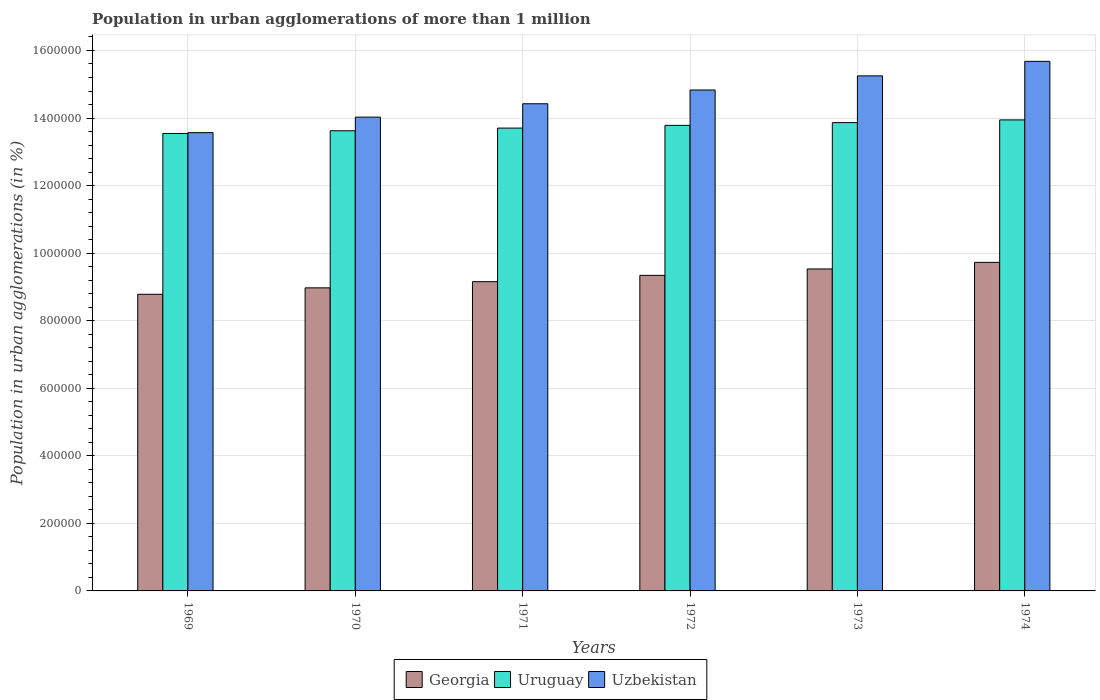How many groups of bars are there?
Your response must be concise. 6. Are the number of bars per tick equal to the number of legend labels?
Offer a very short reply. Yes. What is the label of the 2nd group of bars from the left?
Your answer should be compact. 1970. What is the population in urban agglomerations in Uzbekistan in 1973?
Provide a succinct answer. 1.52e+06. Across all years, what is the maximum population in urban agglomerations in Georgia?
Provide a succinct answer. 9.73e+05. Across all years, what is the minimum population in urban agglomerations in Uruguay?
Provide a short and direct response. 1.35e+06. In which year was the population in urban agglomerations in Uzbekistan maximum?
Provide a succinct answer. 1974. In which year was the population in urban agglomerations in Uzbekistan minimum?
Make the answer very short. 1969. What is the total population in urban agglomerations in Georgia in the graph?
Give a very brief answer. 5.55e+06. What is the difference between the population in urban agglomerations in Uzbekistan in 1969 and that in 1974?
Give a very brief answer. -2.11e+05. What is the difference between the population in urban agglomerations in Uzbekistan in 1974 and the population in urban agglomerations in Uruguay in 1972?
Offer a very short reply. 1.90e+05. What is the average population in urban agglomerations in Uzbekistan per year?
Offer a very short reply. 1.46e+06. In the year 1970, what is the difference between the population in urban agglomerations in Uzbekistan and population in urban agglomerations in Georgia?
Your answer should be compact. 5.05e+05. What is the ratio of the population in urban agglomerations in Georgia in 1970 to that in 1972?
Provide a succinct answer. 0.96. Is the population in urban agglomerations in Uzbekistan in 1969 less than that in 1973?
Provide a succinct answer. Yes. Is the difference between the population in urban agglomerations in Uzbekistan in 1973 and 1974 greater than the difference between the population in urban agglomerations in Georgia in 1973 and 1974?
Offer a very short reply. No. What is the difference between the highest and the second highest population in urban agglomerations in Uzbekistan?
Your answer should be compact. 4.30e+04. What is the difference between the highest and the lowest population in urban agglomerations in Georgia?
Make the answer very short. 9.44e+04. Is the sum of the population in urban agglomerations in Georgia in 1969 and 1974 greater than the maximum population in urban agglomerations in Uzbekistan across all years?
Your response must be concise. Yes. What does the 2nd bar from the left in 1974 represents?
Offer a terse response. Uruguay. What does the 2nd bar from the right in 1973 represents?
Offer a very short reply. Uruguay. Is it the case that in every year, the sum of the population in urban agglomerations in Georgia and population in urban agglomerations in Uzbekistan is greater than the population in urban agglomerations in Uruguay?
Ensure brevity in your answer.  Yes. How many bars are there?
Provide a short and direct response. 18. How many years are there in the graph?
Your answer should be compact. 6. Where does the legend appear in the graph?
Your answer should be compact. Bottom center. What is the title of the graph?
Provide a short and direct response. Population in urban agglomerations of more than 1 million. Does "Equatorial Guinea" appear as one of the legend labels in the graph?
Give a very brief answer. No. What is the label or title of the X-axis?
Keep it short and to the point. Years. What is the label or title of the Y-axis?
Offer a terse response. Population in urban agglomerations (in %). What is the Population in urban agglomerations (in %) of Georgia in 1969?
Offer a terse response. 8.78e+05. What is the Population in urban agglomerations (in %) in Uruguay in 1969?
Keep it short and to the point. 1.35e+06. What is the Population in urban agglomerations (in %) in Uzbekistan in 1969?
Make the answer very short. 1.36e+06. What is the Population in urban agglomerations (in %) in Georgia in 1970?
Your answer should be very brief. 8.97e+05. What is the Population in urban agglomerations (in %) in Uruguay in 1970?
Ensure brevity in your answer.  1.36e+06. What is the Population in urban agglomerations (in %) in Uzbekistan in 1970?
Offer a terse response. 1.40e+06. What is the Population in urban agglomerations (in %) in Georgia in 1971?
Your response must be concise. 9.16e+05. What is the Population in urban agglomerations (in %) of Uruguay in 1971?
Your answer should be compact. 1.37e+06. What is the Population in urban agglomerations (in %) in Uzbekistan in 1971?
Ensure brevity in your answer.  1.44e+06. What is the Population in urban agglomerations (in %) in Georgia in 1972?
Offer a very short reply. 9.34e+05. What is the Population in urban agglomerations (in %) of Uruguay in 1972?
Your answer should be very brief. 1.38e+06. What is the Population in urban agglomerations (in %) in Uzbekistan in 1972?
Your response must be concise. 1.48e+06. What is the Population in urban agglomerations (in %) in Georgia in 1973?
Your answer should be very brief. 9.53e+05. What is the Population in urban agglomerations (in %) in Uruguay in 1973?
Make the answer very short. 1.39e+06. What is the Population in urban agglomerations (in %) of Uzbekistan in 1973?
Provide a succinct answer. 1.52e+06. What is the Population in urban agglomerations (in %) in Georgia in 1974?
Provide a succinct answer. 9.73e+05. What is the Population in urban agglomerations (in %) in Uruguay in 1974?
Make the answer very short. 1.39e+06. What is the Population in urban agglomerations (in %) in Uzbekistan in 1974?
Offer a terse response. 1.57e+06. Across all years, what is the maximum Population in urban agglomerations (in %) of Georgia?
Offer a very short reply. 9.73e+05. Across all years, what is the maximum Population in urban agglomerations (in %) in Uruguay?
Make the answer very short. 1.39e+06. Across all years, what is the maximum Population in urban agglomerations (in %) in Uzbekistan?
Your answer should be very brief. 1.57e+06. Across all years, what is the minimum Population in urban agglomerations (in %) of Georgia?
Your response must be concise. 8.78e+05. Across all years, what is the minimum Population in urban agglomerations (in %) in Uruguay?
Your answer should be compact. 1.35e+06. Across all years, what is the minimum Population in urban agglomerations (in %) in Uzbekistan?
Provide a short and direct response. 1.36e+06. What is the total Population in urban agglomerations (in %) of Georgia in the graph?
Keep it short and to the point. 5.55e+06. What is the total Population in urban agglomerations (in %) in Uruguay in the graph?
Your answer should be very brief. 8.25e+06. What is the total Population in urban agglomerations (in %) of Uzbekistan in the graph?
Offer a very short reply. 8.78e+06. What is the difference between the Population in urban agglomerations (in %) in Georgia in 1969 and that in 1970?
Keep it short and to the point. -1.90e+04. What is the difference between the Population in urban agglomerations (in %) of Uruguay in 1969 and that in 1970?
Ensure brevity in your answer.  -7940. What is the difference between the Population in urban agglomerations (in %) in Uzbekistan in 1969 and that in 1970?
Give a very brief answer. -4.60e+04. What is the difference between the Population in urban agglomerations (in %) in Georgia in 1969 and that in 1971?
Offer a terse response. -3.73e+04. What is the difference between the Population in urban agglomerations (in %) in Uruguay in 1969 and that in 1971?
Make the answer very short. -1.59e+04. What is the difference between the Population in urban agglomerations (in %) of Uzbekistan in 1969 and that in 1971?
Give a very brief answer. -8.56e+04. What is the difference between the Population in urban agglomerations (in %) in Georgia in 1969 and that in 1972?
Keep it short and to the point. -5.60e+04. What is the difference between the Population in urban agglomerations (in %) of Uruguay in 1969 and that in 1972?
Your response must be concise. -2.40e+04. What is the difference between the Population in urban agglomerations (in %) in Uzbekistan in 1969 and that in 1972?
Provide a short and direct response. -1.26e+05. What is the difference between the Population in urban agglomerations (in %) of Georgia in 1969 and that in 1973?
Provide a succinct answer. -7.50e+04. What is the difference between the Population in urban agglomerations (in %) in Uruguay in 1969 and that in 1973?
Your answer should be very brief. -3.20e+04. What is the difference between the Population in urban agglomerations (in %) of Uzbekistan in 1969 and that in 1973?
Provide a succinct answer. -1.68e+05. What is the difference between the Population in urban agglomerations (in %) in Georgia in 1969 and that in 1974?
Ensure brevity in your answer.  -9.44e+04. What is the difference between the Population in urban agglomerations (in %) in Uruguay in 1969 and that in 1974?
Your answer should be compact. -4.02e+04. What is the difference between the Population in urban agglomerations (in %) of Uzbekistan in 1969 and that in 1974?
Provide a succinct answer. -2.11e+05. What is the difference between the Population in urban agglomerations (in %) in Georgia in 1970 and that in 1971?
Your answer should be very brief. -1.83e+04. What is the difference between the Population in urban agglomerations (in %) in Uruguay in 1970 and that in 1971?
Give a very brief answer. -7987. What is the difference between the Population in urban agglomerations (in %) of Uzbekistan in 1970 and that in 1971?
Ensure brevity in your answer.  -3.96e+04. What is the difference between the Population in urban agglomerations (in %) in Georgia in 1970 and that in 1972?
Your answer should be very brief. -3.70e+04. What is the difference between the Population in urban agglomerations (in %) of Uruguay in 1970 and that in 1972?
Give a very brief answer. -1.60e+04. What is the difference between the Population in urban agglomerations (in %) in Uzbekistan in 1970 and that in 1972?
Make the answer very short. -8.03e+04. What is the difference between the Population in urban agglomerations (in %) of Georgia in 1970 and that in 1973?
Ensure brevity in your answer.  -5.60e+04. What is the difference between the Population in urban agglomerations (in %) of Uruguay in 1970 and that in 1973?
Your answer should be very brief. -2.41e+04. What is the difference between the Population in urban agglomerations (in %) in Uzbekistan in 1970 and that in 1973?
Your response must be concise. -1.22e+05. What is the difference between the Population in urban agglomerations (in %) of Georgia in 1970 and that in 1974?
Offer a terse response. -7.54e+04. What is the difference between the Population in urban agglomerations (in %) of Uruguay in 1970 and that in 1974?
Provide a succinct answer. -3.22e+04. What is the difference between the Population in urban agglomerations (in %) in Uzbekistan in 1970 and that in 1974?
Offer a very short reply. -1.65e+05. What is the difference between the Population in urban agglomerations (in %) of Georgia in 1971 and that in 1972?
Keep it short and to the point. -1.87e+04. What is the difference between the Population in urban agglomerations (in %) in Uruguay in 1971 and that in 1972?
Offer a very short reply. -8044. What is the difference between the Population in urban agglomerations (in %) in Uzbekistan in 1971 and that in 1972?
Your answer should be compact. -4.07e+04. What is the difference between the Population in urban agglomerations (in %) in Georgia in 1971 and that in 1973?
Your answer should be very brief. -3.77e+04. What is the difference between the Population in urban agglomerations (in %) in Uruguay in 1971 and that in 1973?
Give a very brief answer. -1.61e+04. What is the difference between the Population in urban agglomerations (in %) of Uzbekistan in 1971 and that in 1973?
Your answer should be very brief. -8.25e+04. What is the difference between the Population in urban agglomerations (in %) in Georgia in 1971 and that in 1974?
Offer a terse response. -5.71e+04. What is the difference between the Population in urban agglomerations (in %) of Uruguay in 1971 and that in 1974?
Keep it short and to the point. -2.42e+04. What is the difference between the Population in urban agglomerations (in %) in Uzbekistan in 1971 and that in 1974?
Give a very brief answer. -1.26e+05. What is the difference between the Population in urban agglomerations (in %) in Georgia in 1972 and that in 1973?
Provide a succinct answer. -1.90e+04. What is the difference between the Population in urban agglomerations (in %) in Uruguay in 1972 and that in 1973?
Offer a terse response. -8070. What is the difference between the Population in urban agglomerations (in %) of Uzbekistan in 1972 and that in 1973?
Keep it short and to the point. -4.18e+04. What is the difference between the Population in urban agglomerations (in %) in Georgia in 1972 and that in 1974?
Give a very brief answer. -3.84e+04. What is the difference between the Population in urban agglomerations (in %) of Uruguay in 1972 and that in 1974?
Your answer should be compact. -1.62e+04. What is the difference between the Population in urban agglomerations (in %) in Uzbekistan in 1972 and that in 1974?
Make the answer very short. -8.48e+04. What is the difference between the Population in urban agglomerations (in %) of Georgia in 1973 and that in 1974?
Your response must be concise. -1.94e+04. What is the difference between the Population in urban agglomerations (in %) of Uruguay in 1973 and that in 1974?
Make the answer very short. -8127. What is the difference between the Population in urban agglomerations (in %) of Uzbekistan in 1973 and that in 1974?
Offer a very short reply. -4.30e+04. What is the difference between the Population in urban agglomerations (in %) of Georgia in 1969 and the Population in urban agglomerations (in %) of Uruguay in 1970?
Offer a very short reply. -4.84e+05. What is the difference between the Population in urban agglomerations (in %) of Georgia in 1969 and the Population in urban agglomerations (in %) of Uzbekistan in 1970?
Keep it short and to the point. -5.24e+05. What is the difference between the Population in urban agglomerations (in %) in Uruguay in 1969 and the Population in urban agglomerations (in %) in Uzbekistan in 1970?
Keep it short and to the point. -4.84e+04. What is the difference between the Population in urban agglomerations (in %) in Georgia in 1969 and the Population in urban agglomerations (in %) in Uruguay in 1971?
Keep it short and to the point. -4.92e+05. What is the difference between the Population in urban agglomerations (in %) in Georgia in 1969 and the Population in urban agglomerations (in %) in Uzbekistan in 1971?
Your answer should be very brief. -5.64e+05. What is the difference between the Population in urban agglomerations (in %) in Uruguay in 1969 and the Population in urban agglomerations (in %) in Uzbekistan in 1971?
Your answer should be compact. -8.80e+04. What is the difference between the Population in urban agglomerations (in %) of Georgia in 1969 and the Population in urban agglomerations (in %) of Uruguay in 1972?
Make the answer very short. -5.00e+05. What is the difference between the Population in urban agglomerations (in %) in Georgia in 1969 and the Population in urban agglomerations (in %) in Uzbekistan in 1972?
Offer a terse response. -6.05e+05. What is the difference between the Population in urban agglomerations (in %) in Uruguay in 1969 and the Population in urban agglomerations (in %) in Uzbekistan in 1972?
Ensure brevity in your answer.  -1.29e+05. What is the difference between the Population in urban agglomerations (in %) of Georgia in 1969 and the Population in urban agglomerations (in %) of Uruguay in 1973?
Make the answer very short. -5.08e+05. What is the difference between the Population in urban agglomerations (in %) in Georgia in 1969 and the Population in urban agglomerations (in %) in Uzbekistan in 1973?
Offer a very short reply. -6.47e+05. What is the difference between the Population in urban agglomerations (in %) of Uruguay in 1969 and the Population in urban agglomerations (in %) of Uzbekistan in 1973?
Keep it short and to the point. -1.70e+05. What is the difference between the Population in urban agglomerations (in %) in Georgia in 1969 and the Population in urban agglomerations (in %) in Uruguay in 1974?
Offer a very short reply. -5.16e+05. What is the difference between the Population in urban agglomerations (in %) of Georgia in 1969 and the Population in urban agglomerations (in %) of Uzbekistan in 1974?
Make the answer very short. -6.90e+05. What is the difference between the Population in urban agglomerations (in %) of Uruguay in 1969 and the Population in urban agglomerations (in %) of Uzbekistan in 1974?
Your answer should be compact. -2.13e+05. What is the difference between the Population in urban agglomerations (in %) of Georgia in 1970 and the Population in urban agglomerations (in %) of Uruguay in 1971?
Provide a succinct answer. -4.73e+05. What is the difference between the Population in urban agglomerations (in %) in Georgia in 1970 and the Population in urban agglomerations (in %) in Uzbekistan in 1971?
Make the answer very short. -5.45e+05. What is the difference between the Population in urban agglomerations (in %) of Uruguay in 1970 and the Population in urban agglomerations (in %) of Uzbekistan in 1971?
Provide a succinct answer. -8.00e+04. What is the difference between the Population in urban agglomerations (in %) of Georgia in 1970 and the Population in urban agglomerations (in %) of Uruguay in 1972?
Provide a short and direct response. -4.81e+05. What is the difference between the Population in urban agglomerations (in %) of Georgia in 1970 and the Population in urban agglomerations (in %) of Uzbekistan in 1972?
Offer a terse response. -5.86e+05. What is the difference between the Population in urban agglomerations (in %) in Uruguay in 1970 and the Population in urban agglomerations (in %) in Uzbekistan in 1972?
Your answer should be compact. -1.21e+05. What is the difference between the Population in urban agglomerations (in %) of Georgia in 1970 and the Population in urban agglomerations (in %) of Uruguay in 1973?
Your answer should be very brief. -4.89e+05. What is the difference between the Population in urban agglomerations (in %) in Georgia in 1970 and the Population in urban agglomerations (in %) in Uzbekistan in 1973?
Offer a very short reply. -6.28e+05. What is the difference between the Population in urban agglomerations (in %) of Uruguay in 1970 and the Population in urban agglomerations (in %) of Uzbekistan in 1973?
Your answer should be compact. -1.63e+05. What is the difference between the Population in urban agglomerations (in %) in Georgia in 1970 and the Population in urban agglomerations (in %) in Uruguay in 1974?
Offer a terse response. -4.97e+05. What is the difference between the Population in urban agglomerations (in %) in Georgia in 1970 and the Population in urban agglomerations (in %) in Uzbekistan in 1974?
Your answer should be very brief. -6.71e+05. What is the difference between the Population in urban agglomerations (in %) of Uruguay in 1970 and the Population in urban agglomerations (in %) of Uzbekistan in 1974?
Your answer should be very brief. -2.06e+05. What is the difference between the Population in urban agglomerations (in %) in Georgia in 1971 and the Population in urban agglomerations (in %) in Uruguay in 1972?
Make the answer very short. -4.63e+05. What is the difference between the Population in urban agglomerations (in %) of Georgia in 1971 and the Population in urban agglomerations (in %) of Uzbekistan in 1972?
Provide a succinct answer. -5.68e+05. What is the difference between the Population in urban agglomerations (in %) in Uruguay in 1971 and the Population in urban agglomerations (in %) in Uzbekistan in 1972?
Provide a succinct answer. -1.13e+05. What is the difference between the Population in urban agglomerations (in %) of Georgia in 1971 and the Population in urban agglomerations (in %) of Uruguay in 1973?
Your answer should be very brief. -4.71e+05. What is the difference between the Population in urban agglomerations (in %) in Georgia in 1971 and the Population in urban agglomerations (in %) in Uzbekistan in 1973?
Ensure brevity in your answer.  -6.09e+05. What is the difference between the Population in urban agglomerations (in %) in Uruguay in 1971 and the Population in urban agglomerations (in %) in Uzbekistan in 1973?
Your answer should be very brief. -1.55e+05. What is the difference between the Population in urban agglomerations (in %) of Georgia in 1971 and the Population in urban agglomerations (in %) of Uruguay in 1974?
Your answer should be very brief. -4.79e+05. What is the difference between the Population in urban agglomerations (in %) in Georgia in 1971 and the Population in urban agglomerations (in %) in Uzbekistan in 1974?
Give a very brief answer. -6.52e+05. What is the difference between the Population in urban agglomerations (in %) of Uruguay in 1971 and the Population in urban agglomerations (in %) of Uzbekistan in 1974?
Give a very brief answer. -1.98e+05. What is the difference between the Population in urban agglomerations (in %) of Georgia in 1972 and the Population in urban agglomerations (in %) of Uruguay in 1973?
Your answer should be compact. -4.52e+05. What is the difference between the Population in urban agglomerations (in %) in Georgia in 1972 and the Population in urban agglomerations (in %) in Uzbekistan in 1973?
Your response must be concise. -5.91e+05. What is the difference between the Population in urban agglomerations (in %) of Uruguay in 1972 and the Population in urban agglomerations (in %) of Uzbekistan in 1973?
Provide a short and direct response. -1.46e+05. What is the difference between the Population in urban agglomerations (in %) of Georgia in 1972 and the Population in urban agglomerations (in %) of Uruguay in 1974?
Your answer should be compact. -4.60e+05. What is the difference between the Population in urban agglomerations (in %) of Georgia in 1972 and the Population in urban agglomerations (in %) of Uzbekistan in 1974?
Provide a short and direct response. -6.34e+05. What is the difference between the Population in urban agglomerations (in %) in Uruguay in 1972 and the Population in urban agglomerations (in %) in Uzbekistan in 1974?
Your answer should be compact. -1.90e+05. What is the difference between the Population in urban agglomerations (in %) of Georgia in 1973 and the Population in urban agglomerations (in %) of Uruguay in 1974?
Offer a very short reply. -4.41e+05. What is the difference between the Population in urban agglomerations (in %) of Georgia in 1973 and the Population in urban agglomerations (in %) of Uzbekistan in 1974?
Your answer should be very brief. -6.15e+05. What is the difference between the Population in urban agglomerations (in %) of Uruguay in 1973 and the Population in urban agglomerations (in %) of Uzbekistan in 1974?
Provide a short and direct response. -1.81e+05. What is the average Population in urban agglomerations (in %) of Georgia per year?
Make the answer very short. 9.25e+05. What is the average Population in urban agglomerations (in %) of Uruguay per year?
Provide a short and direct response. 1.37e+06. What is the average Population in urban agglomerations (in %) in Uzbekistan per year?
Ensure brevity in your answer.  1.46e+06. In the year 1969, what is the difference between the Population in urban agglomerations (in %) in Georgia and Population in urban agglomerations (in %) in Uruguay?
Your response must be concise. -4.76e+05. In the year 1969, what is the difference between the Population in urban agglomerations (in %) in Georgia and Population in urban agglomerations (in %) in Uzbekistan?
Offer a very short reply. -4.78e+05. In the year 1969, what is the difference between the Population in urban agglomerations (in %) in Uruguay and Population in urban agglomerations (in %) in Uzbekistan?
Provide a succinct answer. -2393. In the year 1970, what is the difference between the Population in urban agglomerations (in %) in Georgia and Population in urban agglomerations (in %) in Uruguay?
Provide a short and direct response. -4.65e+05. In the year 1970, what is the difference between the Population in urban agglomerations (in %) of Georgia and Population in urban agglomerations (in %) of Uzbekistan?
Your answer should be compact. -5.05e+05. In the year 1970, what is the difference between the Population in urban agglomerations (in %) in Uruguay and Population in urban agglomerations (in %) in Uzbekistan?
Offer a very short reply. -4.04e+04. In the year 1971, what is the difference between the Population in urban agglomerations (in %) of Georgia and Population in urban agglomerations (in %) of Uruguay?
Your response must be concise. -4.55e+05. In the year 1971, what is the difference between the Population in urban agglomerations (in %) in Georgia and Population in urban agglomerations (in %) in Uzbekistan?
Keep it short and to the point. -5.27e+05. In the year 1971, what is the difference between the Population in urban agglomerations (in %) in Uruguay and Population in urban agglomerations (in %) in Uzbekistan?
Offer a terse response. -7.20e+04. In the year 1972, what is the difference between the Population in urban agglomerations (in %) of Georgia and Population in urban agglomerations (in %) of Uruguay?
Give a very brief answer. -4.44e+05. In the year 1972, what is the difference between the Population in urban agglomerations (in %) in Georgia and Population in urban agglomerations (in %) in Uzbekistan?
Your answer should be very brief. -5.49e+05. In the year 1972, what is the difference between the Population in urban agglomerations (in %) of Uruguay and Population in urban agglomerations (in %) of Uzbekistan?
Offer a very short reply. -1.05e+05. In the year 1973, what is the difference between the Population in urban agglomerations (in %) in Georgia and Population in urban agglomerations (in %) in Uruguay?
Offer a terse response. -4.33e+05. In the year 1973, what is the difference between the Population in urban agglomerations (in %) in Georgia and Population in urban agglomerations (in %) in Uzbekistan?
Give a very brief answer. -5.72e+05. In the year 1973, what is the difference between the Population in urban agglomerations (in %) of Uruguay and Population in urban agglomerations (in %) of Uzbekistan?
Your answer should be compact. -1.38e+05. In the year 1974, what is the difference between the Population in urban agglomerations (in %) in Georgia and Population in urban agglomerations (in %) in Uruguay?
Your answer should be compact. -4.22e+05. In the year 1974, what is the difference between the Population in urban agglomerations (in %) of Georgia and Population in urban agglomerations (in %) of Uzbekistan?
Ensure brevity in your answer.  -5.95e+05. In the year 1974, what is the difference between the Population in urban agglomerations (in %) of Uruguay and Population in urban agglomerations (in %) of Uzbekistan?
Offer a terse response. -1.73e+05. What is the ratio of the Population in urban agglomerations (in %) in Georgia in 1969 to that in 1970?
Offer a very short reply. 0.98. What is the ratio of the Population in urban agglomerations (in %) in Uruguay in 1969 to that in 1970?
Give a very brief answer. 0.99. What is the ratio of the Population in urban agglomerations (in %) of Uzbekistan in 1969 to that in 1970?
Provide a short and direct response. 0.97. What is the ratio of the Population in urban agglomerations (in %) in Georgia in 1969 to that in 1971?
Offer a very short reply. 0.96. What is the ratio of the Population in urban agglomerations (in %) of Uruguay in 1969 to that in 1971?
Provide a short and direct response. 0.99. What is the ratio of the Population in urban agglomerations (in %) in Uzbekistan in 1969 to that in 1971?
Ensure brevity in your answer.  0.94. What is the ratio of the Population in urban agglomerations (in %) in Georgia in 1969 to that in 1972?
Provide a succinct answer. 0.94. What is the ratio of the Population in urban agglomerations (in %) of Uruguay in 1969 to that in 1972?
Offer a terse response. 0.98. What is the ratio of the Population in urban agglomerations (in %) of Uzbekistan in 1969 to that in 1972?
Provide a short and direct response. 0.91. What is the ratio of the Population in urban agglomerations (in %) of Georgia in 1969 to that in 1973?
Ensure brevity in your answer.  0.92. What is the ratio of the Population in urban agglomerations (in %) in Uruguay in 1969 to that in 1973?
Offer a terse response. 0.98. What is the ratio of the Population in urban agglomerations (in %) of Uzbekistan in 1969 to that in 1973?
Give a very brief answer. 0.89. What is the ratio of the Population in urban agglomerations (in %) of Georgia in 1969 to that in 1974?
Offer a terse response. 0.9. What is the ratio of the Population in urban agglomerations (in %) in Uruguay in 1969 to that in 1974?
Your answer should be very brief. 0.97. What is the ratio of the Population in urban agglomerations (in %) in Uzbekistan in 1969 to that in 1974?
Provide a succinct answer. 0.87. What is the ratio of the Population in urban agglomerations (in %) of Uruguay in 1970 to that in 1971?
Ensure brevity in your answer.  0.99. What is the ratio of the Population in urban agglomerations (in %) of Uzbekistan in 1970 to that in 1971?
Your answer should be compact. 0.97. What is the ratio of the Population in urban agglomerations (in %) of Georgia in 1970 to that in 1972?
Offer a very short reply. 0.96. What is the ratio of the Population in urban agglomerations (in %) in Uruguay in 1970 to that in 1972?
Offer a very short reply. 0.99. What is the ratio of the Population in urban agglomerations (in %) in Uzbekistan in 1970 to that in 1972?
Offer a terse response. 0.95. What is the ratio of the Population in urban agglomerations (in %) of Georgia in 1970 to that in 1973?
Give a very brief answer. 0.94. What is the ratio of the Population in urban agglomerations (in %) of Uruguay in 1970 to that in 1973?
Ensure brevity in your answer.  0.98. What is the ratio of the Population in urban agglomerations (in %) in Uzbekistan in 1970 to that in 1973?
Your answer should be very brief. 0.92. What is the ratio of the Population in urban agglomerations (in %) in Georgia in 1970 to that in 1974?
Offer a very short reply. 0.92. What is the ratio of the Population in urban agglomerations (in %) of Uruguay in 1970 to that in 1974?
Keep it short and to the point. 0.98. What is the ratio of the Population in urban agglomerations (in %) in Uzbekistan in 1970 to that in 1974?
Give a very brief answer. 0.89. What is the ratio of the Population in urban agglomerations (in %) of Georgia in 1971 to that in 1972?
Your answer should be compact. 0.98. What is the ratio of the Population in urban agglomerations (in %) in Uzbekistan in 1971 to that in 1972?
Offer a terse response. 0.97. What is the ratio of the Population in urban agglomerations (in %) in Georgia in 1971 to that in 1973?
Keep it short and to the point. 0.96. What is the ratio of the Population in urban agglomerations (in %) in Uruguay in 1971 to that in 1973?
Provide a succinct answer. 0.99. What is the ratio of the Population in urban agglomerations (in %) of Uzbekistan in 1971 to that in 1973?
Make the answer very short. 0.95. What is the ratio of the Population in urban agglomerations (in %) in Georgia in 1971 to that in 1974?
Give a very brief answer. 0.94. What is the ratio of the Population in urban agglomerations (in %) in Uruguay in 1971 to that in 1974?
Your answer should be very brief. 0.98. What is the ratio of the Population in urban agglomerations (in %) in Uzbekistan in 1971 to that in 1974?
Offer a terse response. 0.92. What is the ratio of the Population in urban agglomerations (in %) in Georgia in 1972 to that in 1973?
Your response must be concise. 0.98. What is the ratio of the Population in urban agglomerations (in %) of Uruguay in 1972 to that in 1973?
Your response must be concise. 0.99. What is the ratio of the Population in urban agglomerations (in %) in Uzbekistan in 1972 to that in 1973?
Provide a short and direct response. 0.97. What is the ratio of the Population in urban agglomerations (in %) in Georgia in 1972 to that in 1974?
Ensure brevity in your answer.  0.96. What is the ratio of the Population in urban agglomerations (in %) of Uruguay in 1972 to that in 1974?
Your response must be concise. 0.99. What is the ratio of the Population in urban agglomerations (in %) in Uzbekistan in 1972 to that in 1974?
Give a very brief answer. 0.95. What is the ratio of the Population in urban agglomerations (in %) of Uzbekistan in 1973 to that in 1974?
Provide a short and direct response. 0.97. What is the difference between the highest and the second highest Population in urban agglomerations (in %) of Georgia?
Your answer should be very brief. 1.94e+04. What is the difference between the highest and the second highest Population in urban agglomerations (in %) of Uruguay?
Your answer should be very brief. 8127. What is the difference between the highest and the second highest Population in urban agglomerations (in %) of Uzbekistan?
Make the answer very short. 4.30e+04. What is the difference between the highest and the lowest Population in urban agglomerations (in %) in Georgia?
Provide a succinct answer. 9.44e+04. What is the difference between the highest and the lowest Population in urban agglomerations (in %) in Uruguay?
Offer a terse response. 4.02e+04. What is the difference between the highest and the lowest Population in urban agglomerations (in %) in Uzbekistan?
Your answer should be very brief. 2.11e+05. 